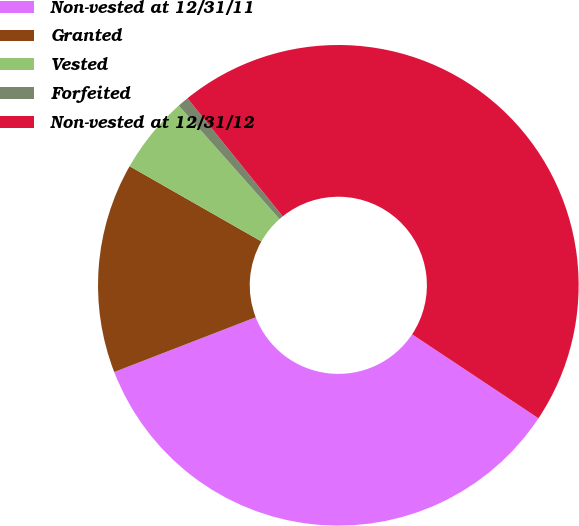<chart> <loc_0><loc_0><loc_500><loc_500><pie_chart><fcel>Non-vested at 12/31/11<fcel>Granted<fcel>Vested<fcel>Forfeited<fcel>Non-vested at 12/31/12<nl><fcel>34.79%<fcel>14.13%<fcel>5.19%<fcel>0.75%<fcel>45.14%<nl></chart> 